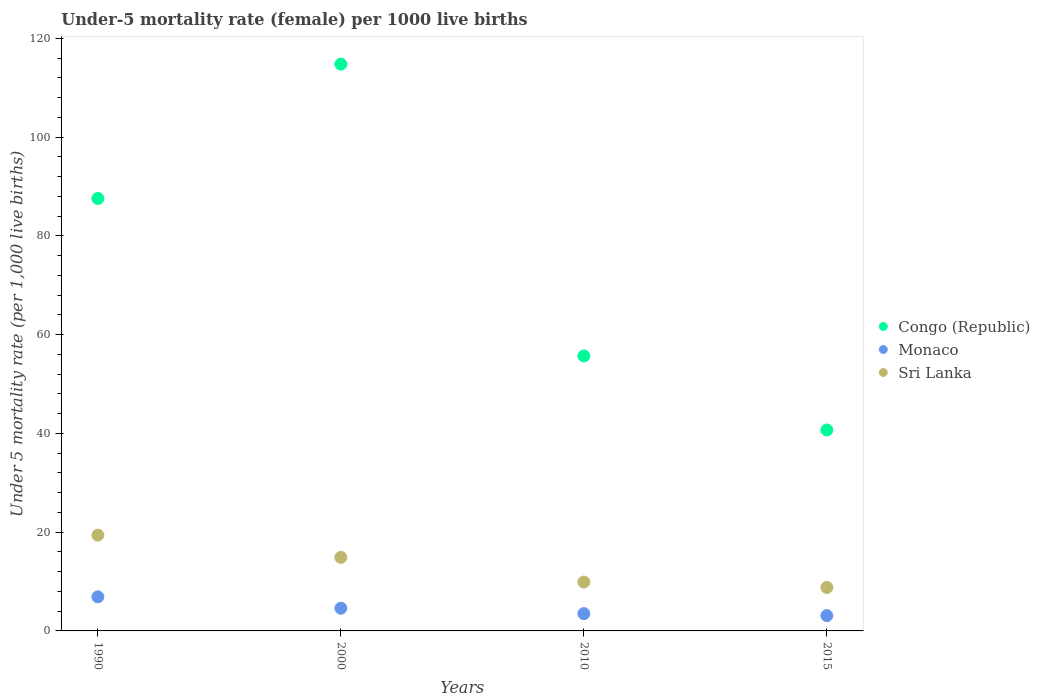How many different coloured dotlines are there?
Give a very brief answer. 3. Is the number of dotlines equal to the number of legend labels?
Make the answer very short. Yes. What is the under-five mortality rate in Congo (Republic) in 2000?
Your answer should be very brief. 114.8. Across all years, what is the maximum under-five mortality rate in Sri Lanka?
Offer a terse response. 19.4. Across all years, what is the minimum under-five mortality rate in Monaco?
Offer a very short reply. 3.1. In which year was the under-five mortality rate in Monaco maximum?
Offer a very short reply. 1990. In which year was the under-five mortality rate in Monaco minimum?
Offer a terse response. 2015. What is the total under-five mortality rate in Congo (Republic) in the graph?
Your answer should be compact. 298.8. What is the difference between the under-five mortality rate in Congo (Republic) in 1990 and that in 2000?
Offer a very short reply. -27.2. What is the difference between the under-five mortality rate in Congo (Republic) in 2000 and the under-five mortality rate in Sri Lanka in 2010?
Your response must be concise. 104.9. What is the average under-five mortality rate in Sri Lanka per year?
Your response must be concise. 13.25. What is the ratio of the under-five mortality rate in Monaco in 2000 to that in 2010?
Make the answer very short. 1.31. What is the difference between the highest and the second highest under-five mortality rate in Congo (Republic)?
Give a very brief answer. 27.2. What is the difference between the highest and the lowest under-five mortality rate in Monaco?
Give a very brief answer. 3.8. In how many years, is the under-five mortality rate in Monaco greater than the average under-five mortality rate in Monaco taken over all years?
Give a very brief answer. 2. Is it the case that in every year, the sum of the under-five mortality rate in Monaco and under-five mortality rate in Sri Lanka  is greater than the under-five mortality rate in Congo (Republic)?
Keep it short and to the point. No. Does the under-five mortality rate in Congo (Republic) monotonically increase over the years?
Your answer should be compact. No. Is the under-five mortality rate in Monaco strictly greater than the under-five mortality rate in Congo (Republic) over the years?
Ensure brevity in your answer.  No. Are the values on the major ticks of Y-axis written in scientific E-notation?
Offer a very short reply. No. Does the graph contain any zero values?
Your answer should be very brief. No. Where does the legend appear in the graph?
Offer a very short reply. Center right. What is the title of the graph?
Make the answer very short. Under-5 mortality rate (female) per 1000 live births. Does "Latin America(all income levels)" appear as one of the legend labels in the graph?
Your response must be concise. No. What is the label or title of the X-axis?
Give a very brief answer. Years. What is the label or title of the Y-axis?
Provide a succinct answer. Under 5 mortality rate (per 1,0 live births). What is the Under 5 mortality rate (per 1,000 live births) of Congo (Republic) in 1990?
Keep it short and to the point. 87.6. What is the Under 5 mortality rate (per 1,000 live births) of Monaco in 1990?
Make the answer very short. 6.9. What is the Under 5 mortality rate (per 1,000 live births) in Congo (Republic) in 2000?
Keep it short and to the point. 114.8. What is the Under 5 mortality rate (per 1,000 live births) in Monaco in 2000?
Your response must be concise. 4.6. What is the Under 5 mortality rate (per 1,000 live births) in Sri Lanka in 2000?
Your response must be concise. 14.9. What is the Under 5 mortality rate (per 1,000 live births) in Congo (Republic) in 2010?
Your response must be concise. 55.7. What is the Under 5 mortality rate (per 1,000 live births) of Monaco in 2010?
Offer a very short reply. 3.5. What is the Under 5 mortality rate (per 1,000 live births) in Congo (Republic) in 2015?
Keep it short and to the point. 40.7. What is the Under 5 mortality rate (per 1,000 live births) of Monaco in 2015?
Your answer should be compact. 3.1. Across all years, what is the maximum Under 5 mortality rate (per 1,000 live births) in Congo (Republic)?
Keep it short and to the point. 114.8. Across all years, what is the maximum Under 5 mortality rate (per 1,000 live births) in Monaco?
Your answer should be very brief. 6.9. Across all years, what is the minimum Under 5 mortality rate (per 1,000 live births) of Congo (Republic)?
Ensure brevity in your answer.  40.7. Across all years, what is the minimum Under 5 mortality rate (per 1,000 live births) in Monaco?
Provide a succinct answer. 3.1. Across all years, what is the minimum Under 5 mortality rate (per 1,000 live births) of Sri Lanka?
Offer a very short reply. 8.8. What is the total Under 5 mortality rate (per 1,000 live births) in Congo (Republic) in the graph?
Provide a short and direct response. 298.8. What is the total Under 5 mortality rate (per 1,000 live births) of Sri Lanka in the graph?
Offer a terse response. 53. What is the difference between the Under 5 mortality rate (per 1,000 live births) in Congo (Republic) in 1990 and that in 2000?
Provide a short and direct response. -27.2. What is the difference between the Under 5 mortality rate (per 1,000 live births) of Monaco in 1990 and that in 2000?
Make the answer very short. 2.3. What is the difference between the Under 5 mortality rate (per 1,000 live births) in Sri Lanka in 1990 and that in 2000?
Provide a succinct answer. 4.5. What is the difference between the Under 5 mortality rate (per 1,000 live births) of Congo (Republic) in 1990 and that in 2010?
Make the answer very short. 31.9. What is the difference between the Under 5 mortality rate (per 1,000 live births) in Congo (Republic) in 1990 and that in 2015?
Make the answer very short. 46.9. What is the difference between the Under 5 mortality rate (per 1,000 live births) of Monaco in 1990 and that in 2015?
Ensure brevity in your answer.  3.8. What is the difference between the Under 5 mortality rate (per 1,000 live births) of Congo (Republic) in 2000 and that in 2010?
Give a very brief answer. 59.1. What is the difference between the Under 5 mortality rate (per 1,000 live births) in Congo (Republic) in 2000 and that in 2015?
Provide a short and direct response. 74.1. What is the difference between the Under 5 mortality rate (per 1,000 live births) in Monaco in 2000 and that in 2015?
Ensure brevity in your answer.  1.5. What is the difference between the Under 5 mortality rate (per 1,000 live births) of Congo (Republic) in 2010 and that in 2015?
Offer a very short reply. 15. What is the difference between the Under 5 mortality rate (per 1,000 live births) of Sri Lanka in 2010 and that in 2015?
Give a very brief answer. 1.1. What is the difference between the Under 5 mortality rate (per 1,000 live births) in Congo (Republic) in 1990 and the Under 5 mortality rate (per 1,000 live births) in Monaco in 2000?
Keep it short and to the point. 83. What is the difference between the Under 5 mortality rate (per 1,000 live births) in Congo (Republic) in 1990 and the Under 5 mortality rate (per 1,000 live births) in Sri Lanka in 2000?
Give a very brief answer. 72.7. What is the difference between the Under 5 mortality rate (per 1,000 live births) of Congo (Republic) in 1990 and the Under 5 mortality rate (per 1,000 live births) of Monaco in 2010?
Your answer should be very brief. 84.1. What is the difference between the Under 5 mortality rate (per 1,000 live births) of Congo (Republic) in 1990 and the Under 5 mortality rate (per 1,000 live births) of Sri Lanka in 2010?
Make the answer very short. 77.7. What is the difference between the Under 5 mortality rate (per 1,000 live births) in Monaco in 1990 and the Under 5 mortality rate (per 1,000 live births) in Sri Lanka in 2010?
Provide a succinct answer. -3. What is the difference between the Under 5 mortality rate (per 1,000 live births) of Congo (Republic) in 1990 and the Under 5 mortality rate (per 1,000 live births) of Monaco in 2015?
Give a very brief answer. 84.5. What is the difference between the Under 5 mortality rate (per 1,000 live births) in Congo (Republic) in 1990 and the Under 5 mortality rate (per 1,000 live births) in Sri Lanka in 2015?
Ensure brevity in your answer.  78.8. What is the difference between the Under 5 mortality rate (per 1,000 live births) in Congo (Republic) in 2000 and the Under 5 mortality rate (per 1,000 live births) in Monaco in 2010?
Your response must be concise. 111.3. What is the difference between the Under 5 mortality rate (per 1,000 live births) of Congo (Republic) in 2000 and the Under 5 mortality rate (per 1,000 live births) of Sri Lanka in 2010?
Offer a terse response. 104.9. What is the difference between the Under 5 mortality rate (per 1,000 live births) in Monaco in 2000 and the Under 5 mortality rate (per 1,000 live births) in Sri Lanka in 2010?
Your response must be concise. -5.3. What is the difference between the Under 5 mortality rate (per 1,000 live births) in Congo (Republic) in 2000 and the Under 5 mortality rate (per 1,000 live births) in Monaco in 2015?
Your answer should be very brief. 111.7. What is the difference between the Under 5 mortality rate (per 1,000 live births) of Congo (Republic) in 2000 and the Under 5 mortality rate (per 1,000 live births) of Sri Lanka in 2015?
Offer a terse response. 106. What is the difference between the Under 5 mortality rate (per 1,000 live births) of Monaco in 2000 and the Under 5 mortality rate (per 1,000 live births) of Sri Lanka in 2015?
Make the answer very short. -4.2. What is the difference between the Under 5 mortality rate (per 1,000 live births) of Congo (Republic) in 2010 and the Under 5 mortality rate (per 1,000 live births) of Monaco in 2015?
Ensure brevity in your answer.  52.6. What is the difference between the Under 5 mortality rate (per 1,000 live births) in Congo (Republic) in 2010 and the Under 5 mortality rate (per 1,000 live births) in Sri Lanka in 2015?
Provide a short and direct response. 46.9. What is the difference between the Under 5 mortality rate (per 1,000 live births) in Monaco in 2010 and the Under 5 mortality rate (per 1,000 live births) in Sri Lanka in 2015?
Ensure brevity in your answer.  -5.3. What is the average Under 5 mortality rate (per 1,000 live births) of Congo (Republic) per year?
Offer a very short reply. 74.7. What is the average Under 5 mortality rate (per 1,000 live births) of Monaco per year?
Keep it short and to the point. 4.53. What is the average Under 5 mortality rate (per 1,000 live births) of Sri Lanka per year?
Your answer should be compact. 13.25. In the year 1990, what is the difference between the Under 5 mortality rate (per 1,000 live births) of Congo (Republic) and Under 5 mortality rate (per 1,000 live births) of Monaco?
Offer a terse response. 80.7. In the year 1990, what is the difference between the Under 5 mortality rate (per 1,000 live births) in Congo (Republic) and Under 5 mortality rate (per 1,000 live births) in Sri Lanka?
Offer a terse response. 68.2. In the year 2000, what is the difference between the Under 5 mortality rate (per 1,000 live births) in Congo (Republic) and Under 5 mortality rate (per 1,000 live births) in Monaco?
Your answer should be very brief. 110.2. In the year 2000, what is the difference between the Under 5 mortality rate (per 1,000 live births) of Congo (Republic) and Under 5 mortality rate (per 1,000 live births) of Sri Lanka?
Ensure brevity in your answer.  99.9. In the year 2000, what is the difference between the Under 5 mortality rate (per 1,000 live births) of Monaco and Under 5 mortality rate (per 1,000 live births) of Sri Lanka?
Your answer should be very brief. -10.3. In the year 2010, what is the difference between the Under 5 mortality rate (per 1,000 live births) of Congo (Republic) and Under 5 mortality rate (per 1,000 live births) of Monaco?
Provide a short and direct response. 52.2. In the year 2010, what is the difference between the Under 5 mortality rate (per 1,000 live births) of Congo (Republic) and Under 5 mortality rate (per 1,000 live births) of Sri Lanka?
Your answer should be compact. 45.8. In the year 2010, what is the difference between the Under 5 mortality rate (per 1,000 live births) of Monaco and Under 5 mortality rate (per 1,000 live births) of Sri Lanka?
Offer a very short reply. -6.4. In the year 2015, what is the difference between the Under 5 mortality rate (per 1,000 live births) in Congo (Republic) and Under 5 mortality rate (per 1,000 live births) in Monaco?
Offer a terse response. 37.6. In the year 2015, what is the difference between the Under 5 mortality rate (per 1,000 live births) of Congo (Republic) and Under 5 mortality rate (per 1,000 live births) of Sri Lanka?
Offer a terse response. 31.9. In the year 2015, what is the difference between the Under 5 mortality rate (per 1,000 live births) of Monaco and Under 5 mortality rate (per 1,000 live births) of Sri Lanka?
Your answer should be compact. -5.7. What is the ratio of the Under 5 mortality rate (per 1,000 live births) of Congo (Republic) in 1990 to that in 2000?
Offer a terse response. 0.76. What is the ratio of the Under 5 mortality rate (per 1,000 live births) in Monaco in 1990 to that in 2000?
Give a very brief answer. 1.5. What is the ratio of the Under 5 mortality rate (per 1,000 live births) in Sri Lanka in 1990 to that in 2000?
Offer a very short reply. 1.3. What is the ratio of the Under 5 mortality rate (per 1,000 live births) in Congo (Republic) in 1990 to that in 2010?
Keep it short and to the point. 1.57. What is the ratio of the Under 5 mortality rate (per 1,000 live births) in Monaco in 1990 to that in 2010?
Make the answer very short. 1.97. What is the ratio of the Under 5 mortality rate (per 1,000 live births) in Sri Lanka in 1990 to that in 2010?
Ensure brevity in your answer.  1.96. What is the ratio of the Under 5 mortality rate (per 1,000 live births) in Congo (Republic) in 1990 to that in 2015?
Give a very brief answer. 2.15. What is the ratio of the Under 5 mortality rate (per 1,000 live births) in Monaco in 1990 to that in 2015?
Your response must be concise. 2.23. What is the ratio of the Under 5 mortality rate (per 1,000 live births) in Sri Lanka in 1990 to that in 2015?
Offer a terse response. 2.2. What is the ratio of the Under 5 mortality rate (per 1,000 live births) of Congo (Republic) in 2000 to that in 2010?
Give a very brief answer. 2.06. What is the ratio of the Under 5 mortality rate (per 1,000 live births) in Monaco in 2000 to that in 2010?
Your response must be concise. 1.31. What is the ratio of the Under 5 mortality rate (per 1,000 live births) of Sri Lanka in 2000 to that in 2010?
Provide a succinct answer. 1.51. What is the ratio of the Under 5 mortality rate (per 1,000 live births) in Congo (Republic) in 2000 to that in 2015?
Make the answer very short. 2.82. What is the ratio of the Under 5 mortality rate (per 1,000 live births) of Monaco in 2000 to that in 2015?
Your answer should be very brief. 1.48. What is the ratio of the Under 5 mortality rate (per 1,000 live births) of Sri Lanka in 2000 to that in 2015?
Offer a very short reply. 1.69. What is the ratio of the Under 5 mortality rate (per 1,000 live births) in Congo (Republic) in 2010 to that in 2015?
Your response must be concise. 1.37. What is the ratio of the Under 5 mortality rate (per 1,000 live births) in Monaco in 2010 to that in 2015?
Your response must be concise. 1.13. What is the ratio of the Under 5 mortality rate (per 1,000 live births) of Sri Lanka in 2010 to that in 2015?
Your answer should be very brief. 1.12. What is the difference between the highest and the second highest Under 5 mortality rate (per 1,000 live births) of Congo (Republic)?
Give a very brief answer. 27.2. What is the difference between the highest and the second highest Under 5 mortality rate (per 1,000 live births) in Monaco?
Offer a very short reply. 2.3. What is the difference between the highest and the second highest Under 5 mortality rate (per 1,000 live births) in Sri Lanka?
Your answer should be very brief. 4.5. What is the difference between the highest and the lowest Under 5 mortality rate (per 1,000 live births) in Congo (Republic)?
Keep it short and to the point. 74.1. What is the difference between the highest and the lowest Under 5 mortality rate (per 1,000 live births) in Monaco?
Keep it short and to the point. 3.8. 